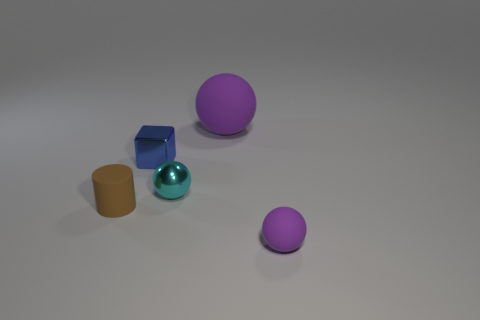Is the color of the big matte thing the same as the tiny rubber thing right of the small blue metallic cube?
Provide a short and direct response. Yes. There is a tiny object that is behind the cyan ball; what is it made of?
Ensure brevity in your answer.  Metal. Is there a small ball that has the same color as the large thing?
Provide a succinct answer. Yes. What color is the cylinder that is the same size as the cyan sphere?
Keep it short and to the point. Brown. How many large objects are cyan metal balls or spheres?
Offer a very short reply. 1. Is the number of balls behind the tiny purple ball the same as the number of tiny objects that are right of the small cube?
Your answer should be compact. Yes. How many purple objects are the same size as the cyan shiny sphere?
Give a very brief answer. 1. What number of red things are large matte things or small shiny blocks?
Give a very brief answer. 0. Are there the same number of small cyan things in front of the blue shiny cube and tiny gray metallic cylinders?
Provide a succinct answer. No. What size is the object in front of the brown matte object?
Keep it short and to the point. Small. 